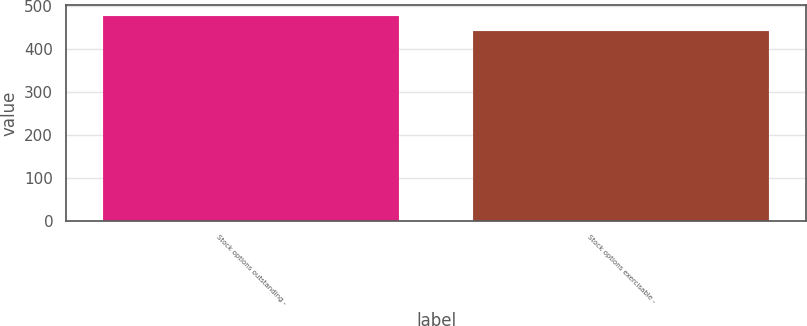<chart> <loc_0><loc_0><loc_500><loc_500><bar_chart><fcel>Stock options outstanding -<fcel>Stock options exercisable -<nl><fcel>477<fcel>441<nl></chart> 